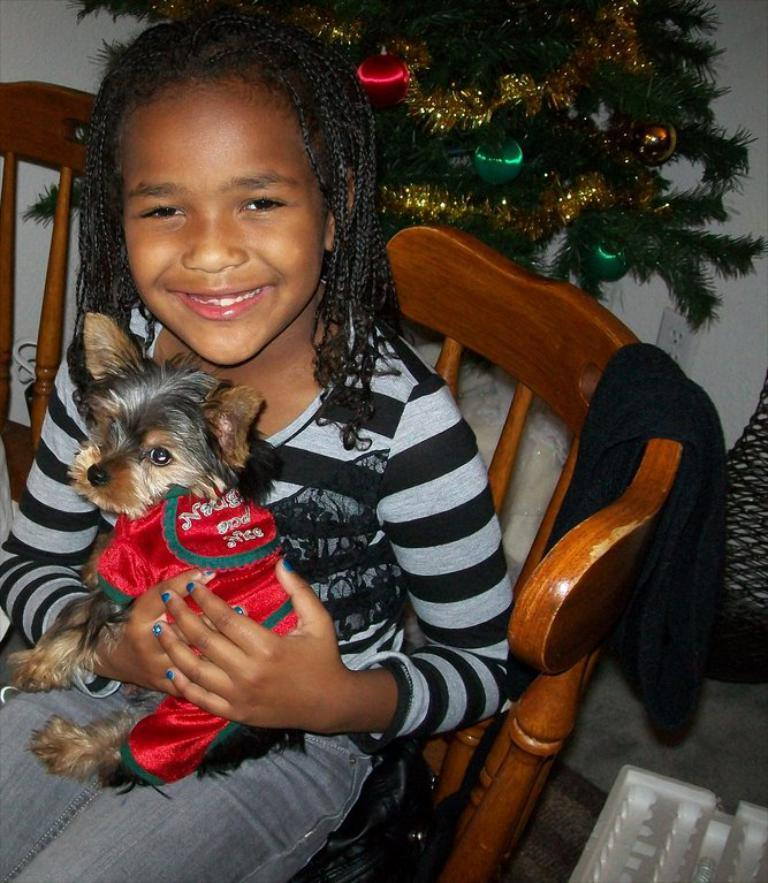What is the main subject of the image? The main subject of the image is a kid. What is the kid holding in the image? The kid is holding a puppy in the image. What is the kid sitting on in the image? The kid is sitting on a chair in the image. What can be seen in the background of the image? There is a plant and a wall in the background of the image. How is the plant decorated in the image? The plant is decorated with balls and ribbon in the image. What type of cake is being discussed by the kid and the puppy in the image? There is no cake or discussion present in the image; the kid is holding a puppy and sitting on a chair. What type of light source is illuminating the scene in the image? The image does not provide information about the light source; it only shows the kid, the puppy, the chair, the plant, and the wall. 